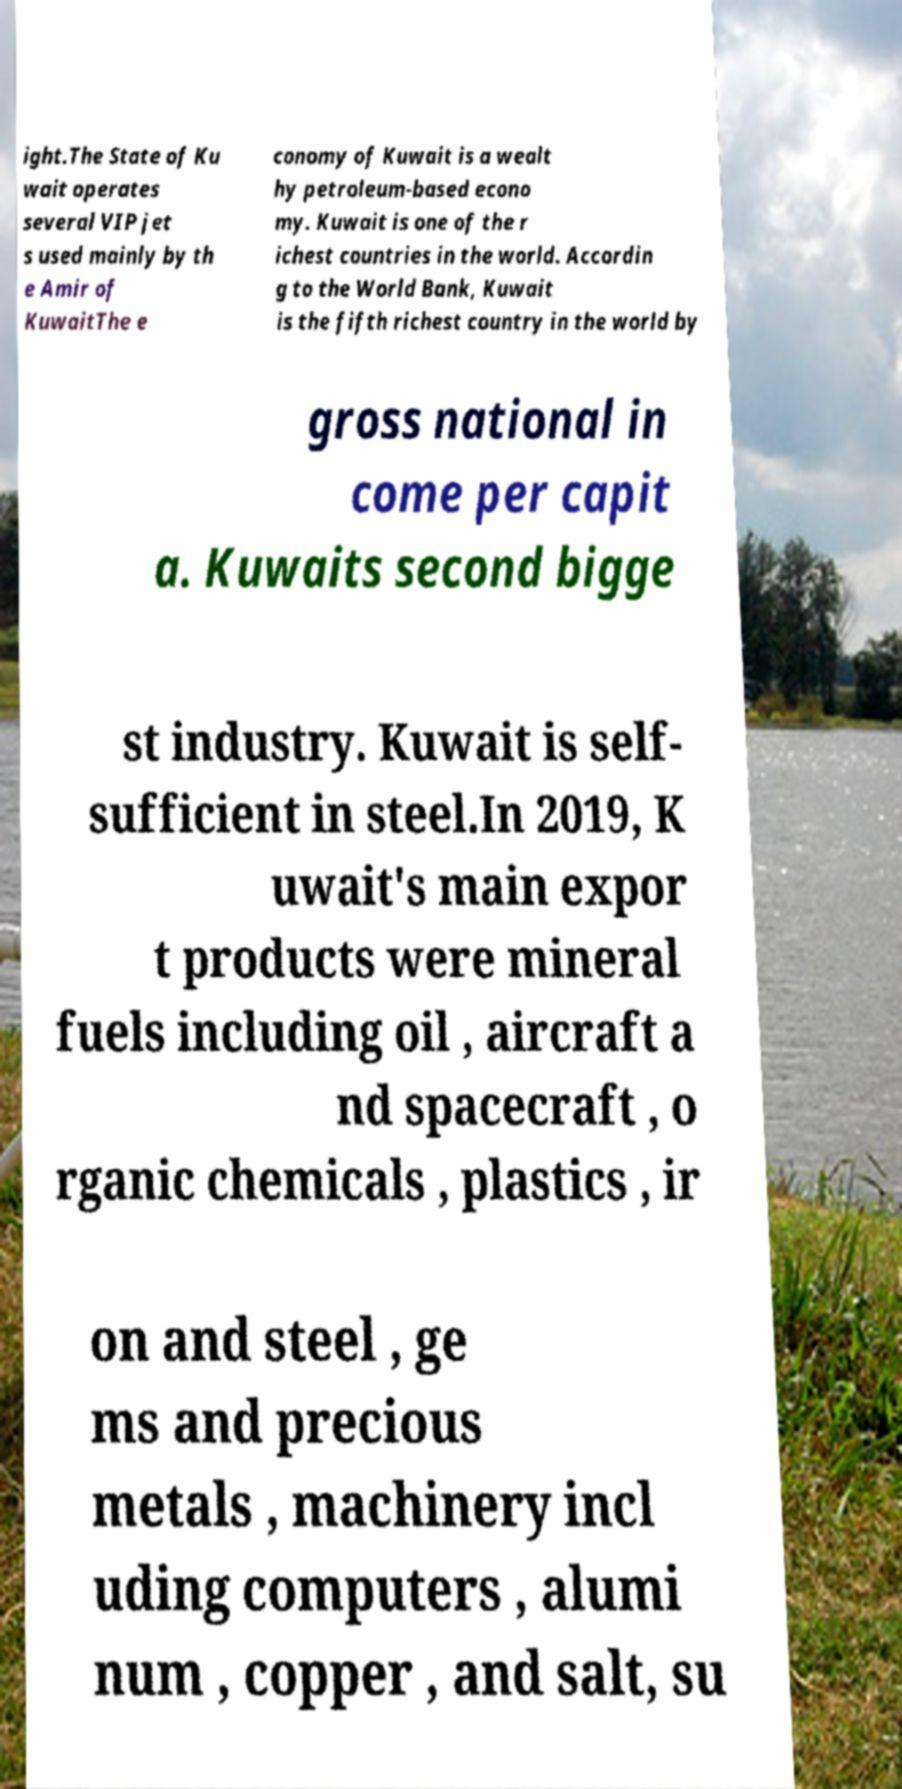Could you extract and type out the text from this image? ight.The State of Ku wait operates several VIP jet s used mainly by th e Amir of KuwaitThe e conomy of Kuwait is a wealt hy petroleum-based econo my. Kuwait is one of the r ichest countries in the world. Accordin g to the World Bank, Kuwait is the fifth richest country in the world by gross national in come per capit a. Kuwaits second bigge st industry. Kuwait is self- sufficient in steel.In 2019, K uwait's main expor t products were mineral fuels including oil , aircraft a nd spacecraft , o rganic chemicals , plastics , ir on and steel , ge ms and precious metals , machinery incl uding computers , alumi num , copper , and salt, su 